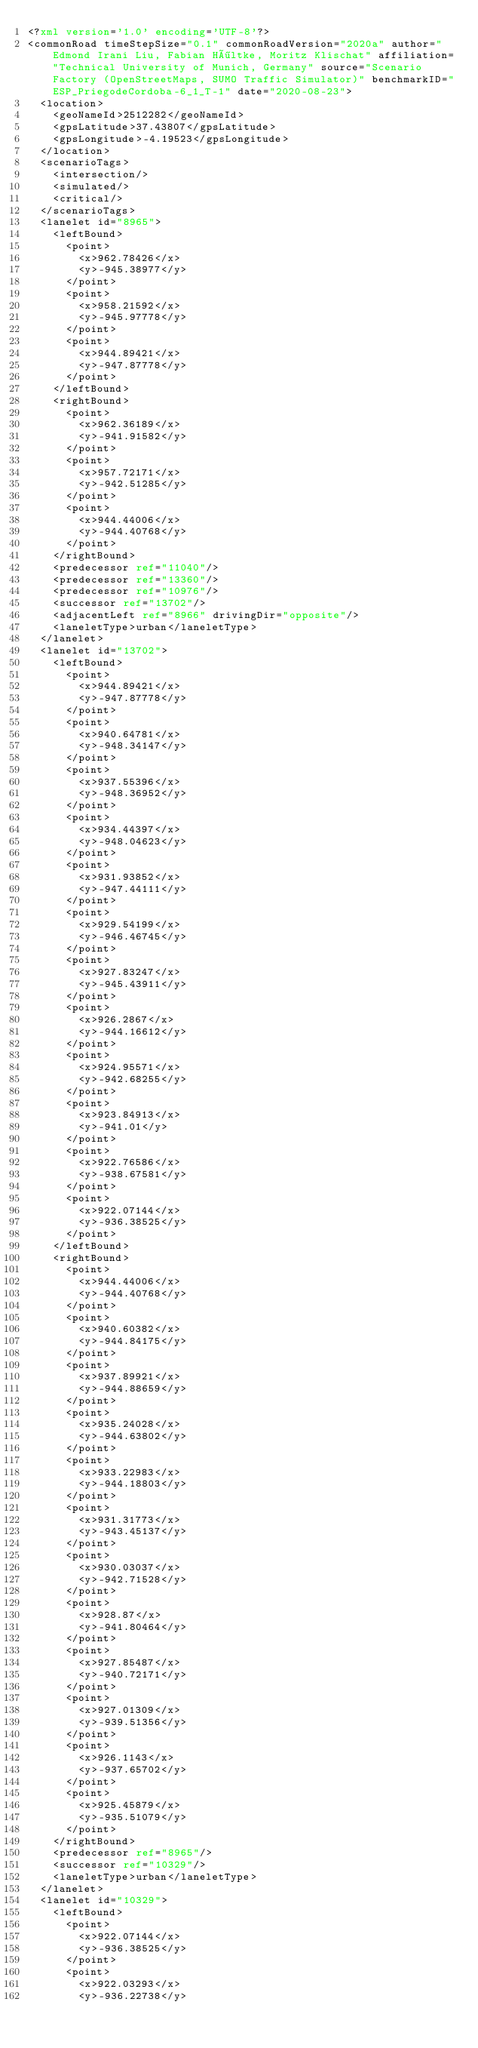Convert code to text. <code><loc_0><loc_0><loc_500><loc_500><_XML_><?xml version='1.0' encoding='UTF-8'?>
<commonRoad timeStepSize="0.1" commonRoadVersion="2020a" author="Edmond Irani Liu, Fabian Höltke, Moritz Klischat" affiliation="Technical University of Munich, Germany" source="Scenario Factory (OpenStreetMaps, SUMO Traffic Simulator)" benchmarkID="ESP_PriegodeCordoba-6_1_T-1" date="2020-08-23">
  <location>
    <geoNameId>2512282</geoNameId>
    <gpsLatitude>37.43807</gpsLatitude>
    <gpsLongitude>-4.19523</gpsLongitude>
  </location>
  <scenarioTags>
    <intersection/>
    <simulated/>
    <critical/>
  </scenarioTags>
  <lanelet id="8965">
    <leftBound>
      <point>
        <x>962.78426</x>
        <y>-945.38977</y>
      </point>
      <point>
        <x>958.21592</x>
        <y>-945.97778</y>
      </point>
      <point>
        <x>944.89421</x>
        <y>-947.87778</y>
      </point>
    </leftBound>
    <rightBound>
      <point>
        <x>962.36189</x>
        <y>-941.91582</y>
      </point>
      <point>
        <x>957.72171</x>
        <y>-942.51285</y>
      </point>
      <point>
        <x>944.44006</x>
        <y>-944.40768</y>
      </point>
    </rightBound>
    <predecessor ref="11040"/>
    <predecessor ref="13360"/>
    <predecessor ref="10976"/>
    <successor ref="13702"/>
    <adjacentLeft ref="8966" drivingDir="opposite"/>
    <laneletType>urban</laneletType>
  </lanelet>
  <lanelet id="13702">
    <leftBound>
      <point>
        <x>944.89421</x>
        <y>-947.87778</y>
      </point>
      <point>
        <x>940.64781</x>
        <y>-948.34147</y>
      </point>
      <point>
        <x>937.55396</x>
        <y>-948.36952</y>
      </point>
      <point>
        <x>934.44397</x>
        <y>-948.04623</y>
      </point>
      <point>
        <x>931.93852</x>
        <y>-947.44111</y>
      </point>
      <point>
        <x>929.54199</x>
        <y>-946.46745</y>
      </point>
      <point>
        <x>927.83247</x>
        <y>-945.43911</y>
      </point>
      <point>
        <x>926.2867</x>
        <y>-944.16612</y>
      </point>
      <point>
        <x>924.95571</x>
        <y>-942.68255</y>
      </point>
      <point>
        <x>923.84913</x>
        <y>-941.01</y>
      </point>
      <point>
        <x>922.76586</x>
        <y>-938.67581</y>
      </point>
      <point>
        <x>922.07144</x>
        <y>-936.38525</y>
      </point>
    </leftBound>
    <rightBound>
      <point>
        <x>944.44006</x>
        <y>-944.40768</y>
      </point>
      <point>
        <x>940.60382</x>
        <y>-944.84175</y>
      </point>
      <point>
        <x>937.89921</x>
        <y>-944.88659</y>
      </point>
      <point>
        <x>935.24028</x>
        <y>-944.63802</y>
      </point>
      <point>
        <x>933.22983</x>
        <y>-944.18803</y>
      </point>
      <point>
        <x>931.31773</x>
        <y>-943.45137</y>
      </point>
      <point>
        <x>930.03037</x>
        <y>-942.71528</y>
      </point>
      <point>
        <x>928.87</x>
        <y>-941.80464</y>
      </point>
      <point>
        <x>927.85487</x>
        <y>-940.72171</y>
      </point>
      <point>
        <x>927.01309</x>
        <y>-939.51356</y>
      </point>
      <point>
        <x>926.1143</x>
        <y>-937.65702</y>
      </point>
      <point>
        <x>925.45879</x>
        <y>-935.51079</y>
      </point>
    </rightBound>
    <predecessor ref="8965"/>
    <successor ref="10329"/>
    <laneletType>urban</laneletType>
  </lanelet>
  <lanelet id="10329">
    <leftBound>
      <point>
        <x>922.07144</x>
        <y>-936.38525</y>
      </point>
      <point>
        <x>922.03293</x>
        <y>-936.22738</y></code> 